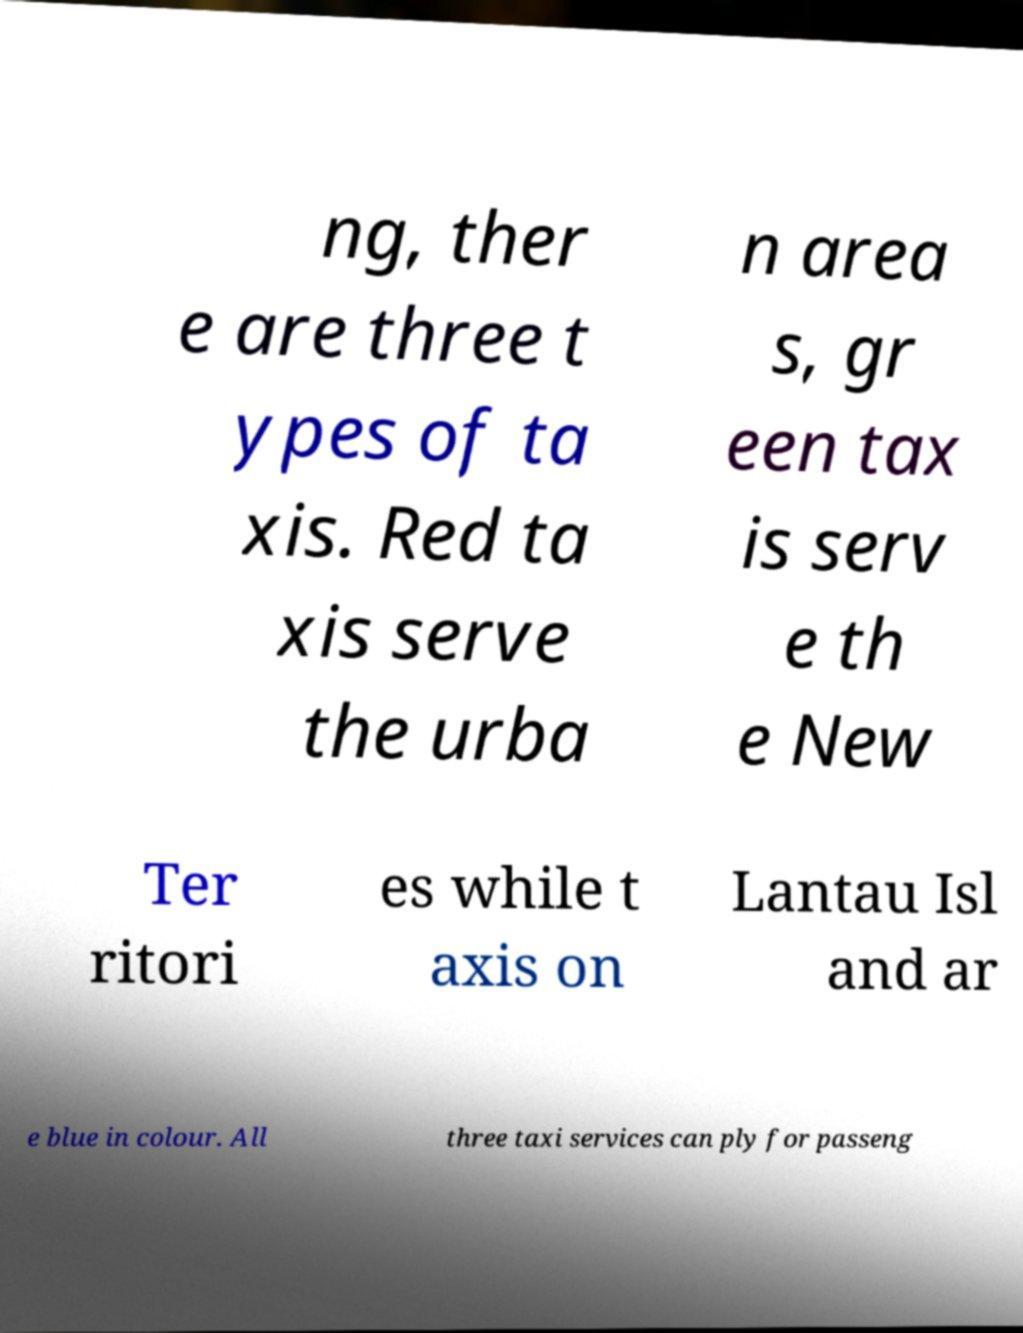Could you extract and type out the text from this image? ng, ther e are three t ypes of ta xis. Red ta xis serve the urba n area s, gr een tax is serv e th e New Ter ritori es while t axis on Lantau Isl and ar e blue in colour. All three taxi services can ply for passeng 